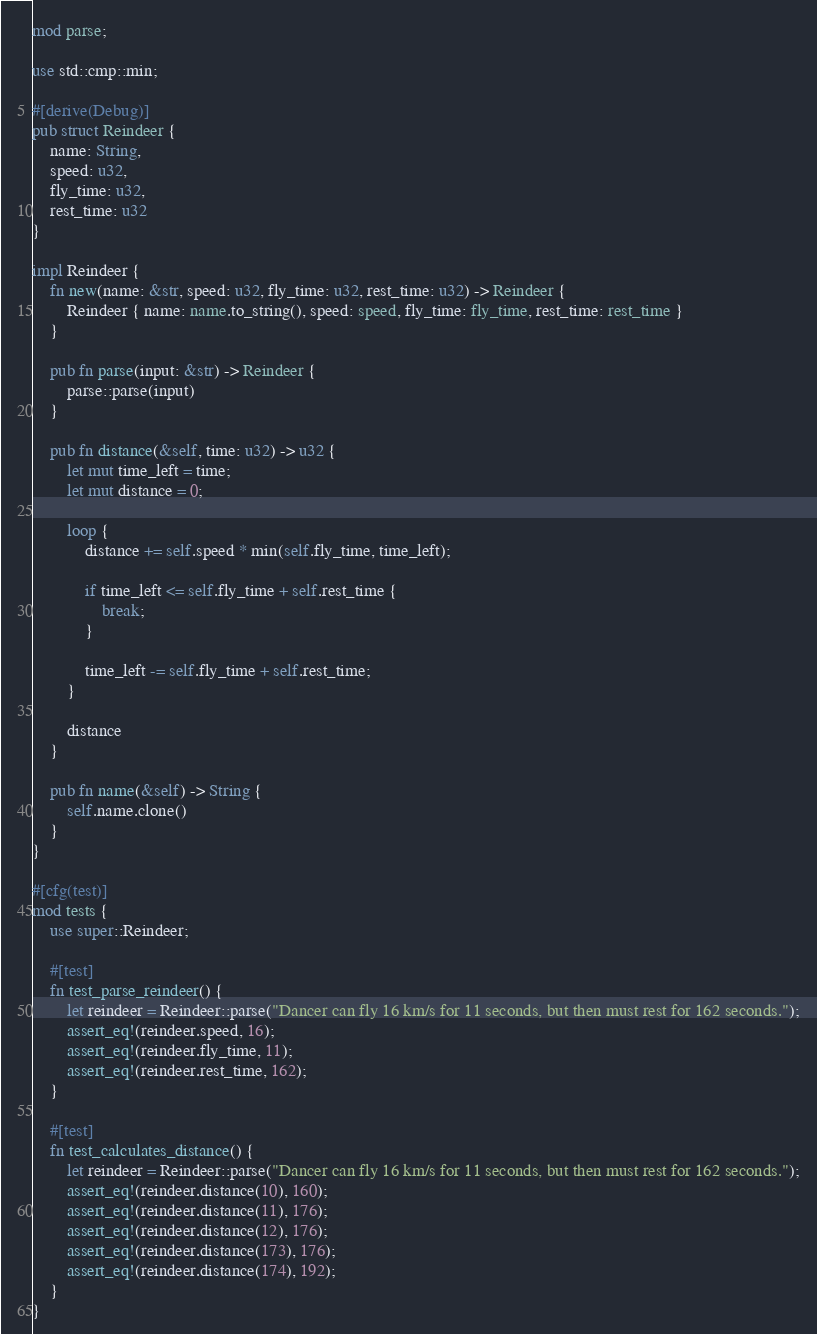Convert code to text. <code><loc_0><loc_0><loc_500><loc_500><_Rust_>mod parse;

use std::cmp::min;

#[derive(Debug)]
pub struct Reindeer {
    name: String,
    speed: u32,
    fly_time: u32,
    rest_time: u32
}

impl Reindeer {
    fn new(name: &str, speed: u32, fly_time: u32, rest_time: u32) -> Reindeer {
        Reindeer { name: name.to_string(), speed: speed, fly_time: fly_time, rest_time: rest_time }
    }

    pub fn parse(input: &str) -> Reindeer {
        parse::parse(input)
    }

    pub fn distance(&self, time: u32) -> u32 {
        let mut time_left = time;
        let mut distance = 0;

        loop {
            distance += self.speed * min(self.fly_time, time_left);

            if time_left <= self.fly_time + self.rest_time {
                break;
            }

            time_left -= self.fly_time + self.rest_time;
        }

        distance
    }

    pub fn name(&self) -> String {
        self.name.clone()
    }
}

#[cfg(test)]
mod tests {
    use super::Reindeer;

    #[test]
    fn test_parse_reindeer() {
        let reindeer = Reindeer::parse("Dancer can fly 16 km/s for 11 seconds, but then must rest for 162 seconds.");
        assert_eq!(reindeer.speed, 16);
        assert_eq!(reindeer.fly_time, 11);
        assert_eq!(reindeer.rest_time, 162);
    }

    #[test]
    fn test_calculates_distance() {
        let reindeer = Reindeer::parse("Dancer can fly 16 km/s for 11 seconds, but then must rest for 162 seconds.");
        assert_eq!(reindeer.distance(10), 160);
        assert_eq!(reindeer.distance(11), 176);
        assert_eq!(reindeer.distance(12), 176);
        assert_eq!(reindeer.distance(173), 176);
        assert_eq!(reindeer.distance(174), 192);
    }
}
</code> 